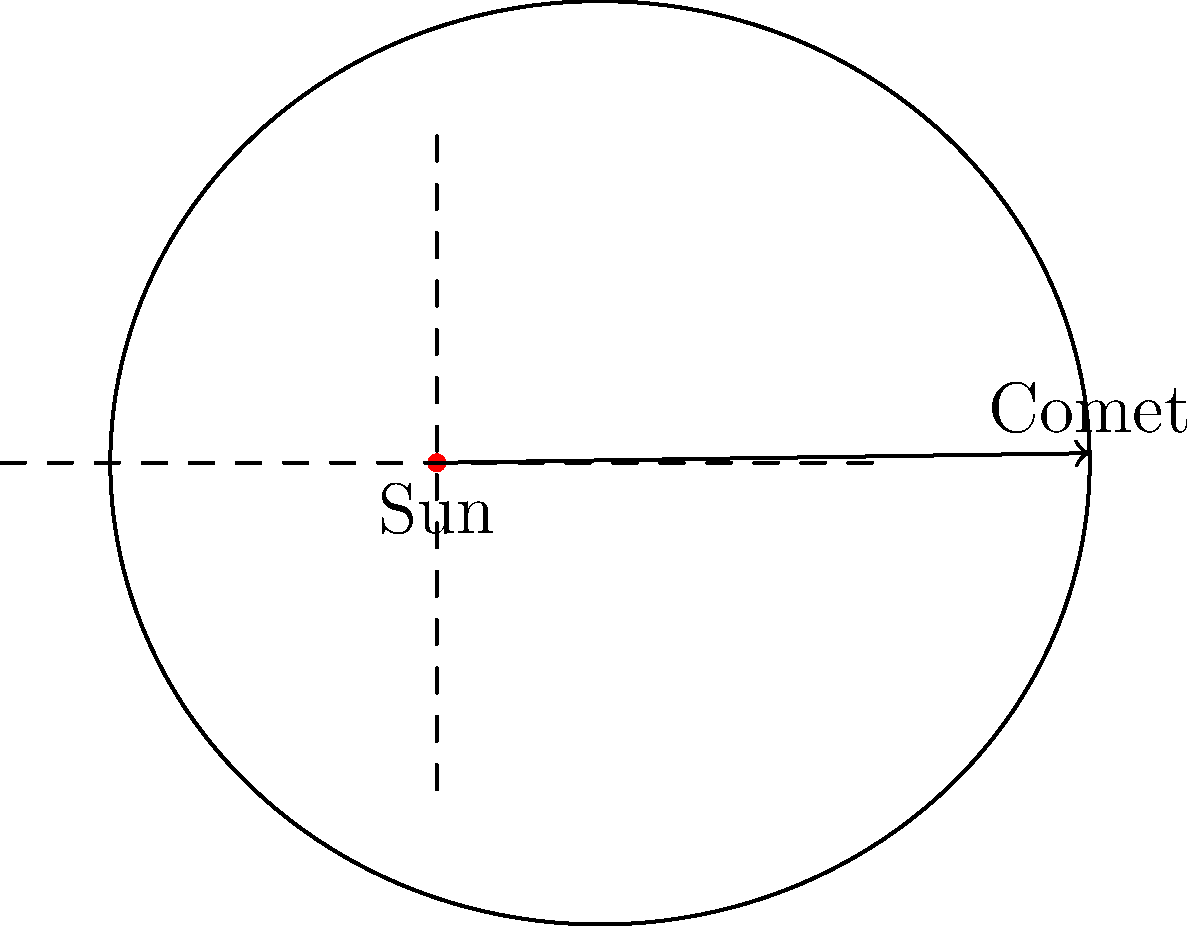In the AR experience of a comet's orbit, how does the comet's velocity change as it moves along its elliptical path around the Sun? Consider the relationship between the comet's distance from the Sun and its speed. To understand the comet's velocity changes, we need to consider Kepler's laws of planetary motion, which also apply to comets:

1. Kepler's First Law: The orbit of a comet is an ellipse with the Sun at one of the two foci.

2. Kepler's Second Law (Law of Equal Areas): A line segment joining a comet and the Sun sweeps out equal areas during equal intervals of time.

3. From these laws, we can deduce that:
   a. The comet's velocity is not constant throughout its orbit.
   b. The velocity is highest when the comet is closest to the Sun (perihelion).
   c. The velocity is lowest when the comet is farthest from the Sun (aphelion).

4. This relationship can be explained by the conservation of angular momentum and energy:
   a. As the comet approaches the Sun, it gains gravitational potential energy.
   b. This potential energy is converted into kinetic energy, increasing the comet's speed.
   c. The opposite occurs as the comet moves away from the Sun.

5. Mathematically, the relationship between the comet's velocity ($v$) and its distance from the Sun ($r$) can be expressed using the vis-viva equation:

   $$ v = \sqrt{GM\left(\frac{2}{r} - \frac{1}{a}\right)} $$

   Where $G$ is the gravitational constant, $M$ is the mass of the Sun, and $a$ is the semi-major axis of the orbit.

6. This equation shows that velocity ($v$) increases as distance ($r$) decreases, and vice versa.
Answer: The comet's velocity increases as it approaches the Sun and decreases as it moves away. 